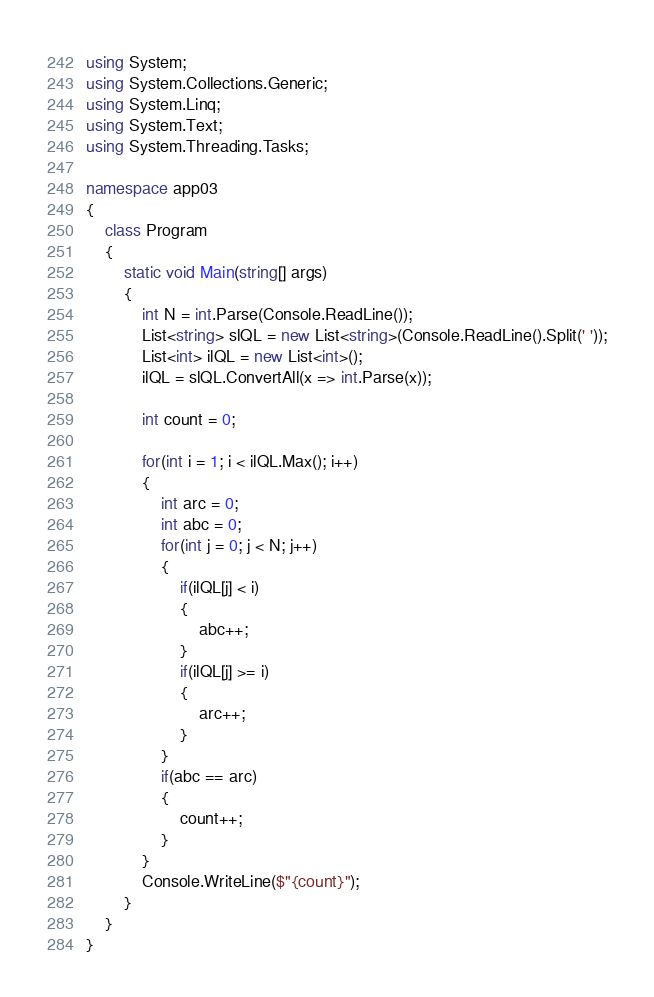Convert code to text. <code><loc_0><loc_0><loc_500><loc_500><_C#_>using System;
using System.Collections.Generic;
using System.Linq;
using System.Text;
using System.Threading.Tasks;

namespace app03
{
    class Program
    {
        static void Main(string[] args)
        {
            int N = int.Parse(Console.ReadLine());
            List<string> slQL = new List<string>(Console.ReadLine().Split(' '));
            List<int> ilQL = new List<int>();
            ilQL = slQL.ConvertAll(x => int.Parse(x));
            
            int count = 0;

            for(int i = 1; i < ilQL.Max(); i++)
            {
                int arc = 0;
                int abc = 0;
                for(int j = 0; j < N; j++)
                {
                    if(ilQL[j] < i)
                    {
                        abc++;
                    }
                    if(ilQL[j] >= i)
                    {
                        arc++;
                    }
                }
                if(abc == arc)
                {
                    count++;
                }
            }
            Console.WriteLine($"{count}");
        }
    }
}
</code> 